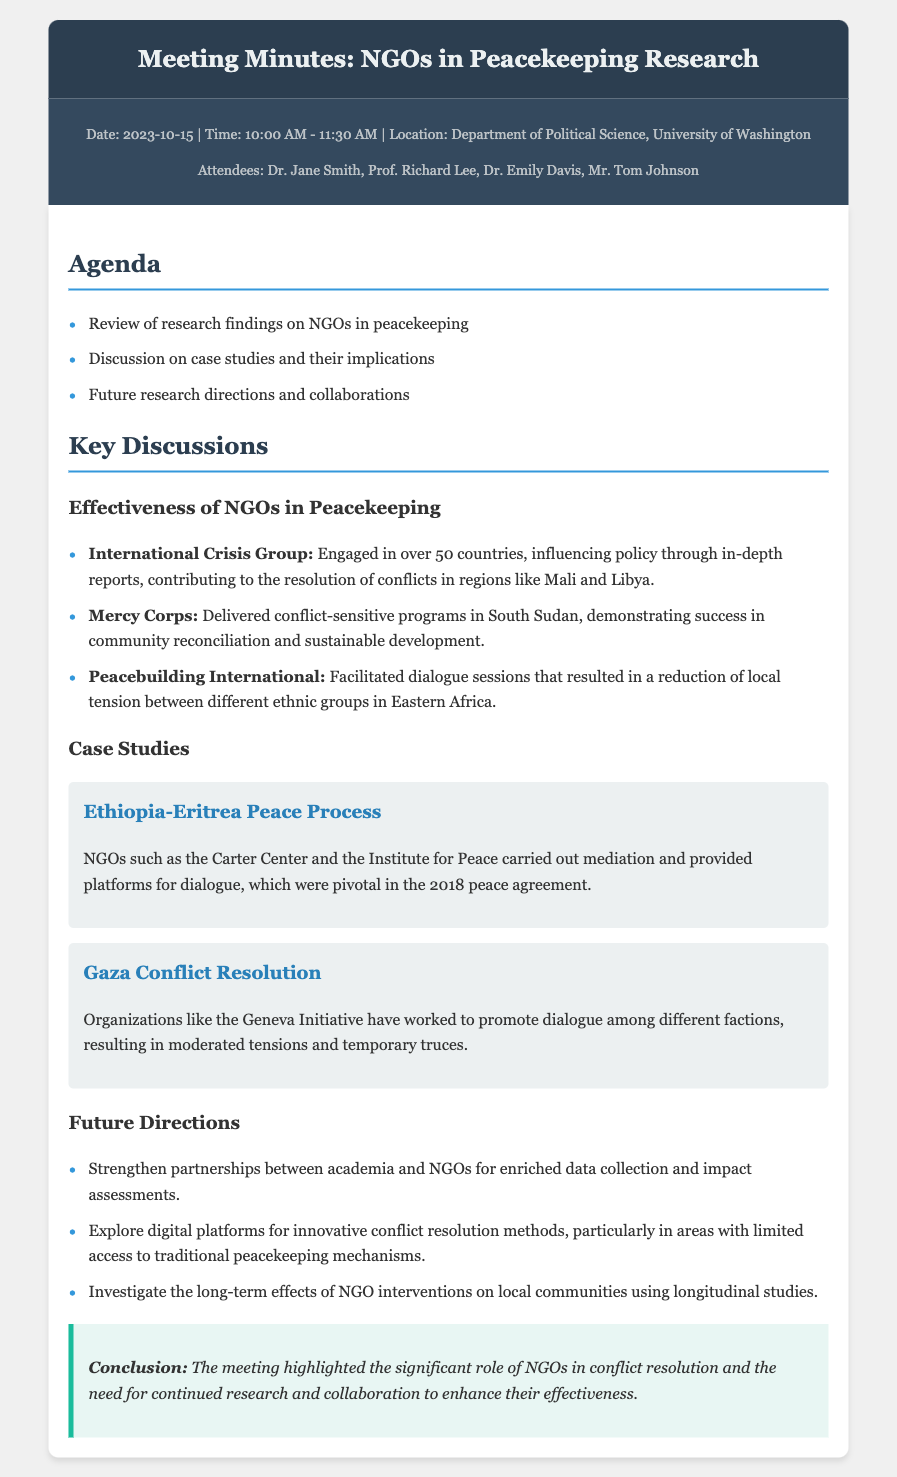What was the date of the meeting? The meeting date is explicitly mentioned in the meta-info section of the document.
Answer: 2023-10-15 Who attended the meeting? The list of attendees is provided in the meta-info section, enumerating everyone present.
Answer: Dr. Jane Smith, Prof. Richard Lee, Dr. Emily Davis, Mr. Tom Johnson Which organization was involved in the Ethiopia-Eritrea peace process? The document specifies NGOs that played a role in this process within the case study section.
Answer: Carter Center, Institute for Peace What key program did Mercy Corps implement in South Sudan? The effectiveness of specific programs by NGOs is discussed in the key discussions section of the document.
Answer: Conflict-sensitive programs What is one future direction for research mentioned? The document lists several future directions, including collaborative opportunities between academia and NGOs.
Answer: Strengthen partnerships between academia and NGOs How many countries is the International Crisis Group engaged in? The number of countries involved is stated in the key discussions section.
Answer: Over 50 countries What ethnic tensions did Peacebuilding International help reduce? The document identifies the type of conflict addressed by Peacebuilding International.
Answer: Tension between different ethnic groups What type of document is this? The structure and content clearly indicate the nature of this document, which is aimed at summarizing the meeting.
Answer: Meeting Minutes 